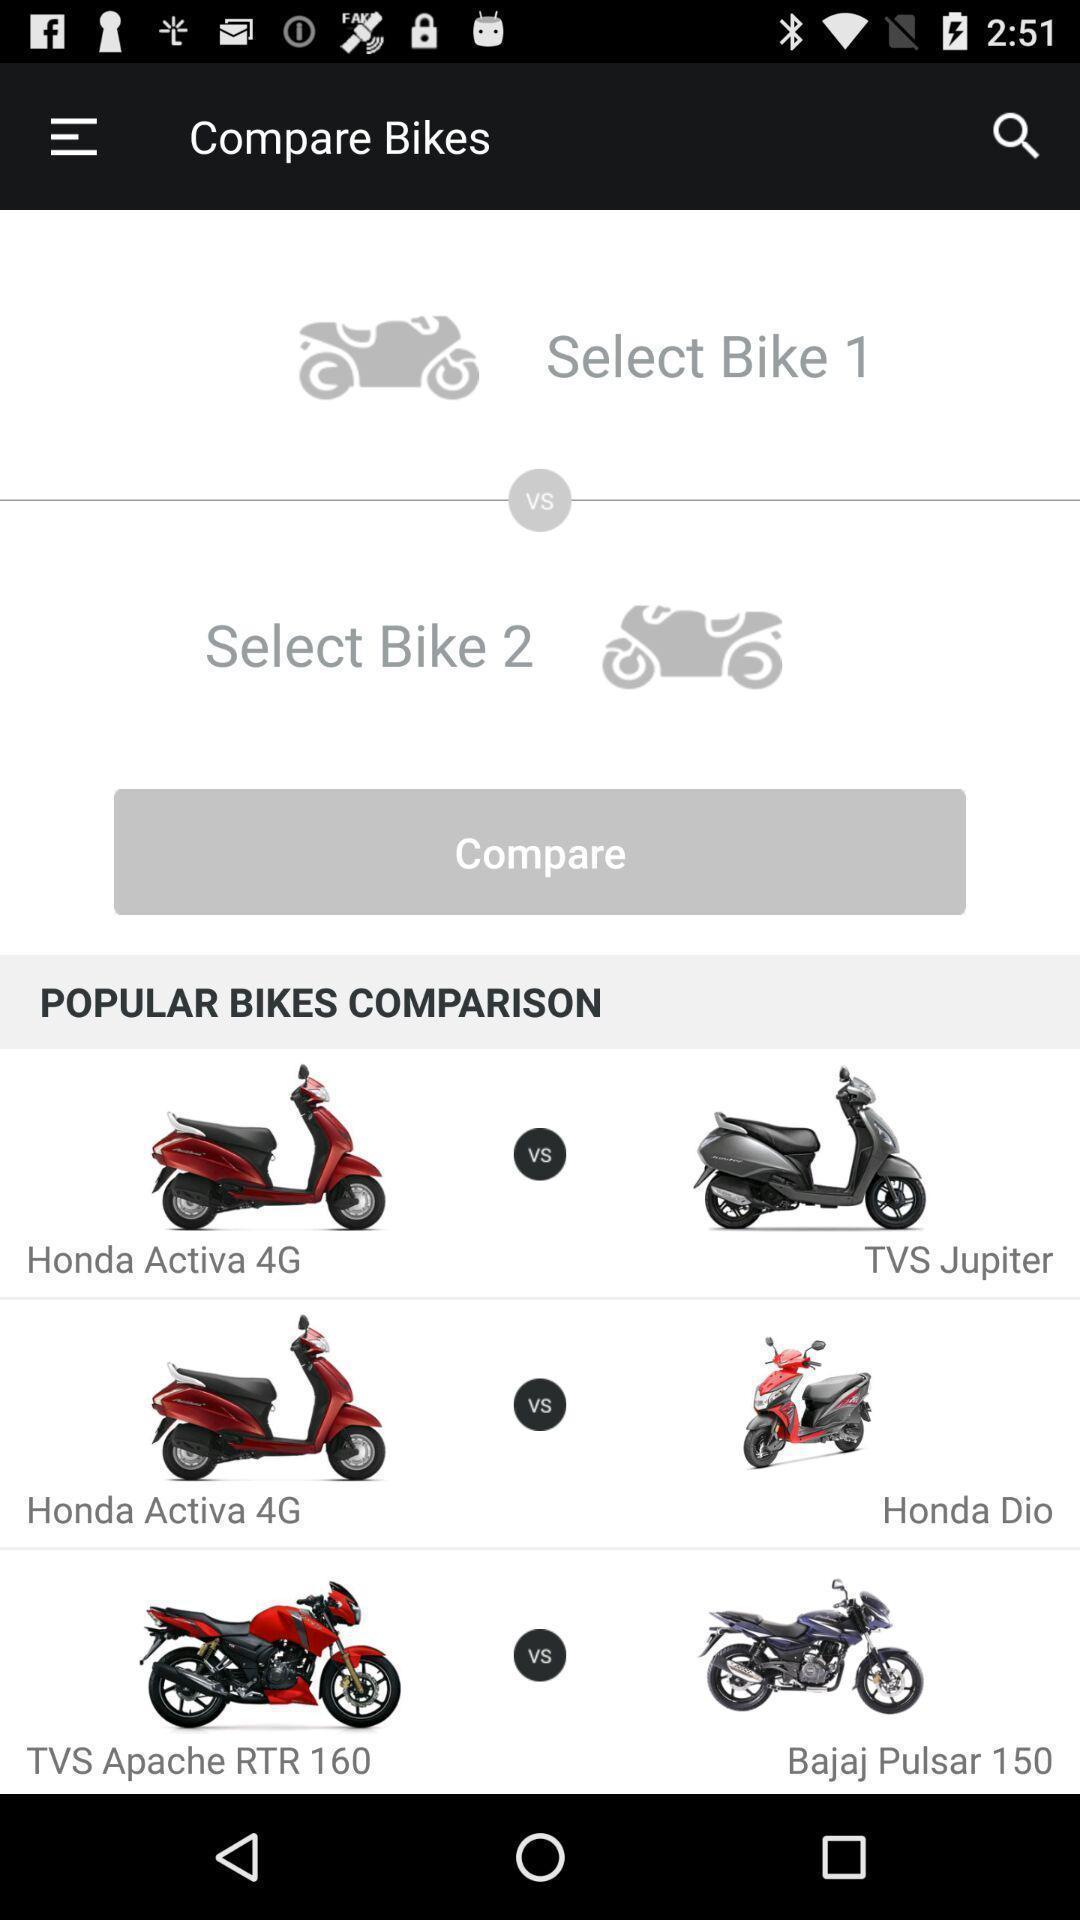Describe the visual elements of this screenshot. Screen displaying comparisons of products. 